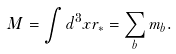Convert formula to latex. <formula><loc_0><loc_0><loc_500><loc_500>M = \int d ^ { 3 } x r _ { * } = \sum _ { b } m _ { b } .</formula> 